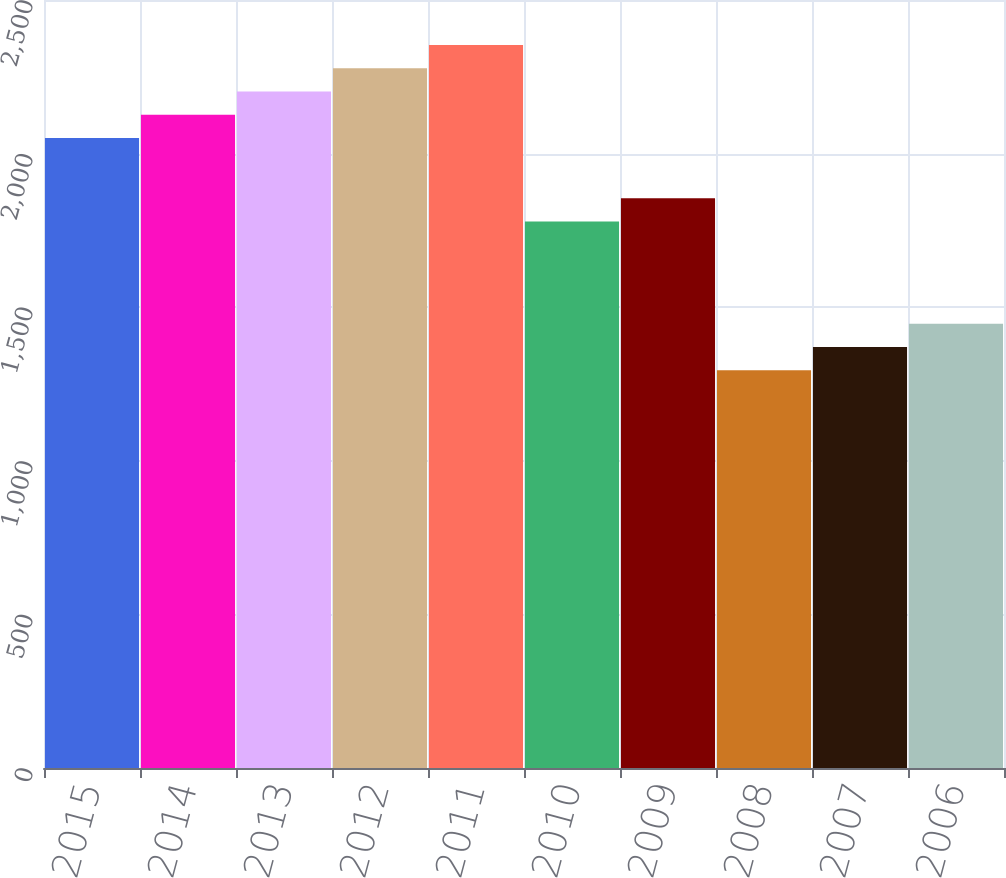Convert chart. <chart><loc_0><loc_0><loc_500><loc_500><bar_chart><fcel>2015<fcel>2014<fcel>2013<fcel>2012<fcel>2011<fcel>2010<fcel>2009<fcel>2008<fcel>2007<fcel>2006<nl><fcel>2051<fcel>2126.6<fcel>2202.2<fcel>2277.8<fcel>2353.4<fcel>1779<fcel>1854.6<fcel>1295<fcel>1370.6<fcel>1446.2<nl></chart> 